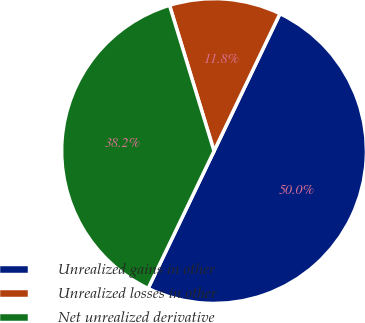<chart> <loc_0><loc_0><loc_500><loc_500><pie_chart><fcel>Unrealized gains in other<fcel>Unrealized losses in other<fcel>Net unrealized derivative<nl><fcel>50.0%<fcel>11.84%<fcel>38.16%<nl></chart> 